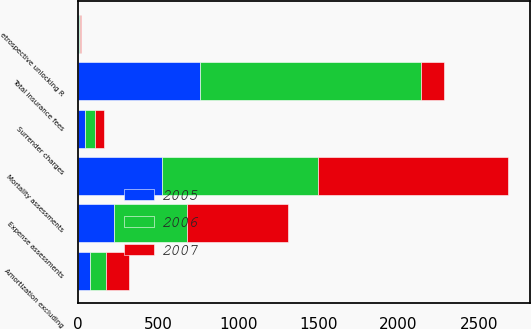Convert chart. <chart><loc_0><loc_0><loc_500><loc_500><stacked_bar_chart><ecel><fcel>Mortality assessments<fcel>Expense assessments<fcel>Surrender charges<fcel>Amortization excluding<fcel>etrospective unlocking R<fcel>Total insurance fees<nl><fcel>2007<fcel>1188<fcel>633<fcel>60<fcel>145<fcel>11<fcel>145<nl><fcel>2006<fcel>970<fcel>457<fcel>60<fcel>103<fcel>7<fcel>1380<nl><fcel>2005<fcel>525<fcel>222<fcel>44<fcel>73<fcel>4<fcel>759<nl></chart> 